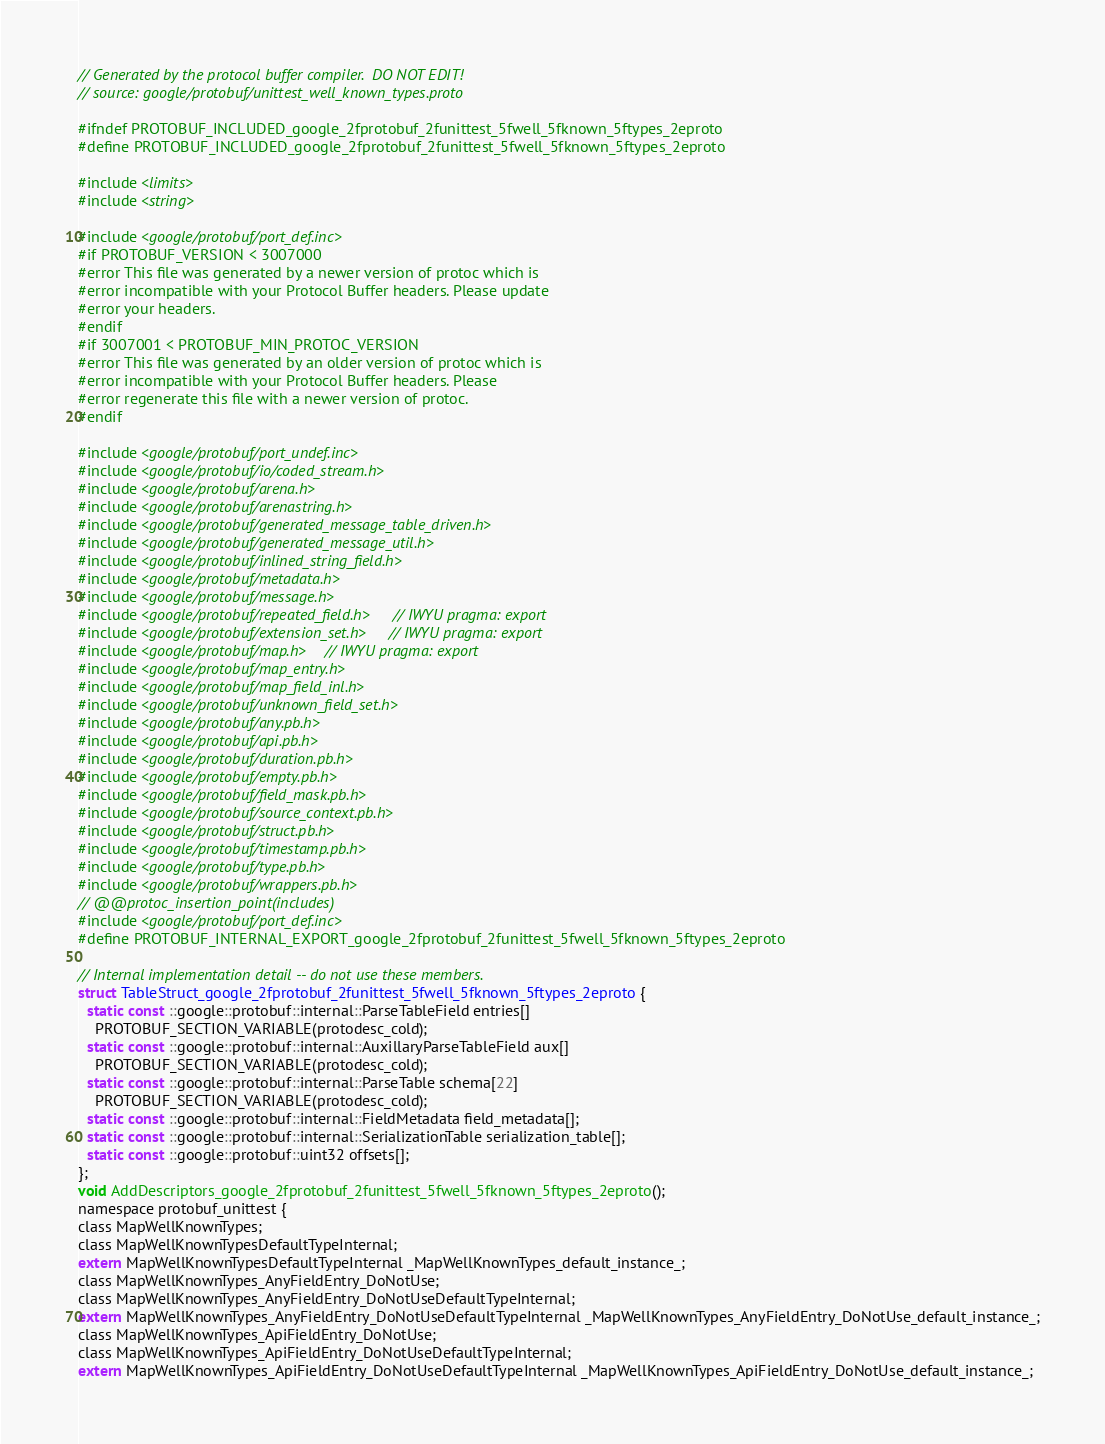Convert code to text. <code><loc_0><loc_0><loc_500><loc_500><_C_>// Generated by the protocol buffer compiler.  DO NOT EDIT!
// source: google/protobuf/unittest_well_known_types.proto

#ifndef PROTOBUF_INCLUDED_google_2fprotobuf_2funittest_5fwell_5fknown_5ftypes_2eproto
#define PROTOBUF_INCLUDED_google_2fprotobuf_2funittest_5fwell_5fknown_5ftypes_2eproto

#include <limits>
#include <string>

#include <google/protobuf/port_def.inc>
#if PROTOBUF_VERSION < 3007000
#error This file was generated by a newer version of protoc which is
#error incompatible with your Protocol Buffer headers. Please update
#error your headers.
#endif
#if 3007001 < PROTOBUF_MIN_PROTOC_VERSION
#error This file was generated by an older version of protoc which is
#error incompatible with your Protocol Buffer headers. Please
#error regenerate this file with a newer version of protoc.
#endif

#include <google/protobuf/port_undef.inc>
#include <google/protobuf/io/coded_stream.h>
#include <google/protobuf/arena.h>
#include <google/protobuf/arenastring.h>
#include <google/protobuf/generated_message_table_driven.h>
#include <google/protobuf/generated_message_util.h>
#include <google/protobuf/inlined_string_field.h>
#include <google/protobuf/metadata.h>
#include <google/protobuf/message.h>
#include <google/protobuf/repeated_field.h>  // IWYU pragma: export
#include <google/protobuf/extension_set.h>  // IWYU pragma: export
#include <google/protobuf/map.h>  // IWYU pragma: export
#include <google/protobuf/map_entry.h>
#include <google/protobuf/map_field_inl.h>
#include <google/protobuf/unknown_field_set.h>
#include <google/protobuf/any.pb.h>
#include <google/protobuf/api.pb.h>
#include <google/protobuf/duration.pb.h>
#include <google/protobuf/empty.pb.h>
#include <google/protobuf/field_mask.pb.h>
#include <google/protobuf/source_context.pb.h>
#include <google/protobuf/struct.pb.h>
#include <google/protobuf/timestamp.pb.h>
#include <google/protobuf/type.pb.h>
#include <google/protobuf/wrappers.pb.h>
// @@protoc_insertion_point(includes)
#include <google/protobuf/port_def.inc>
#define PROTOBUF_INTERNAL_EXPORT_google_2fprotobuf_2funittest_5fwell_5fknown_5ftypes_2eproto

// Internal implementation detail -- do not use these members.
struct TableStruct_google_2fprotobuf_2funittest_5fwell_5fknown_5ftypes_2eproto {
  static const ::google::protobuf::internal::ParseTableField entries[]
    PROTOBUF_SECTION_VARIABLE(protodesc_cold);
  static const ::google::protobuf::internal::AuxillaryParseTableField aux[]
    PROTOBUF_SECTION_VARIABLE(protodesc_cold);
  static const ::google::protobuf::internal::ParseTable schema[22]
    PROTOBUF_SECTION_VARIABLE(protodesc_cold);
  static const ::google::protobuf::internal::FieldMetadata field_metadata[];
  static const ::google::protobuf::internal::SerializationTable serialization_table[];
  static const ::google::protobuf::uint32 offsets[];
};
void AddDescriptors_google_2fprotobuf_2funittest_5fwell_5fknown_5ftypes_2eproto();
namespace protobuf_unittest {
class MapWellKnownTypes;
class MapWellKnownTypesDefaultTypeInternal;
extern MapWellKnownTypesDefaultTypeInternal _MapWellKnownTypes_default_instance_;
class MapWellKnownTypes_AnyFieldEntry_DoNotUse;
class MapWellKnownTypes_AnyFieldEntry_DoNotUseDefaultTypeInternal;
extern MapWellKnownTypes_AnyFieldEntry_DoNotUseDefaultTypeInternal _MapWellKnownTypes_AnyFieldEntry_DoNotUse_default_instance_;
class MapWellKnownTypes_ApiFieldEntry_DoNotUse;
class MapWellKnownTypes_ApiFieldEntry_DoNotUseDefaultTypeInternal;
extern MapWellKnownTypes_ApiFieldEntry_DoNotUseDefaultTypeInternal _MapWellKnownTypes_ApiFieldEntry_DoNotUse_default_instance_;</code> 